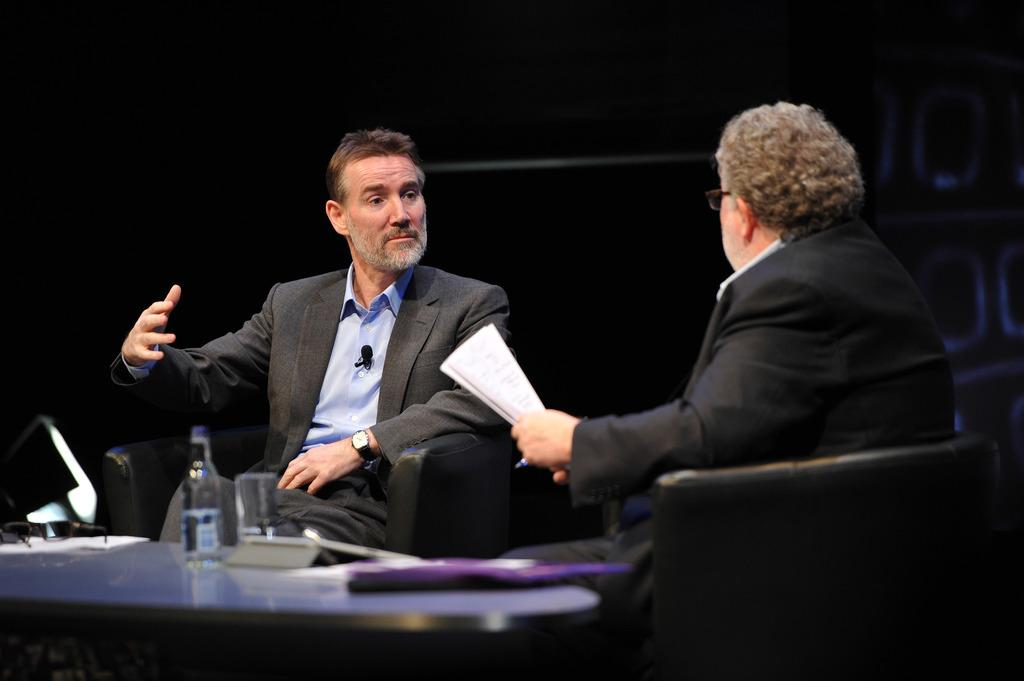How many people are in the image? There are two men in the image. What are the men doing in the image? The men are sitting opposite each other and talking. What is one of the men holding? One of the men is holding papers. What is present on the table in the image? There is a table in the image, and on it, there is a water bottle and a glass. What word is the self-proclaimed weightlifter saying in the image? There is no self-proclaimed weightlifter or any word being said in the image. 